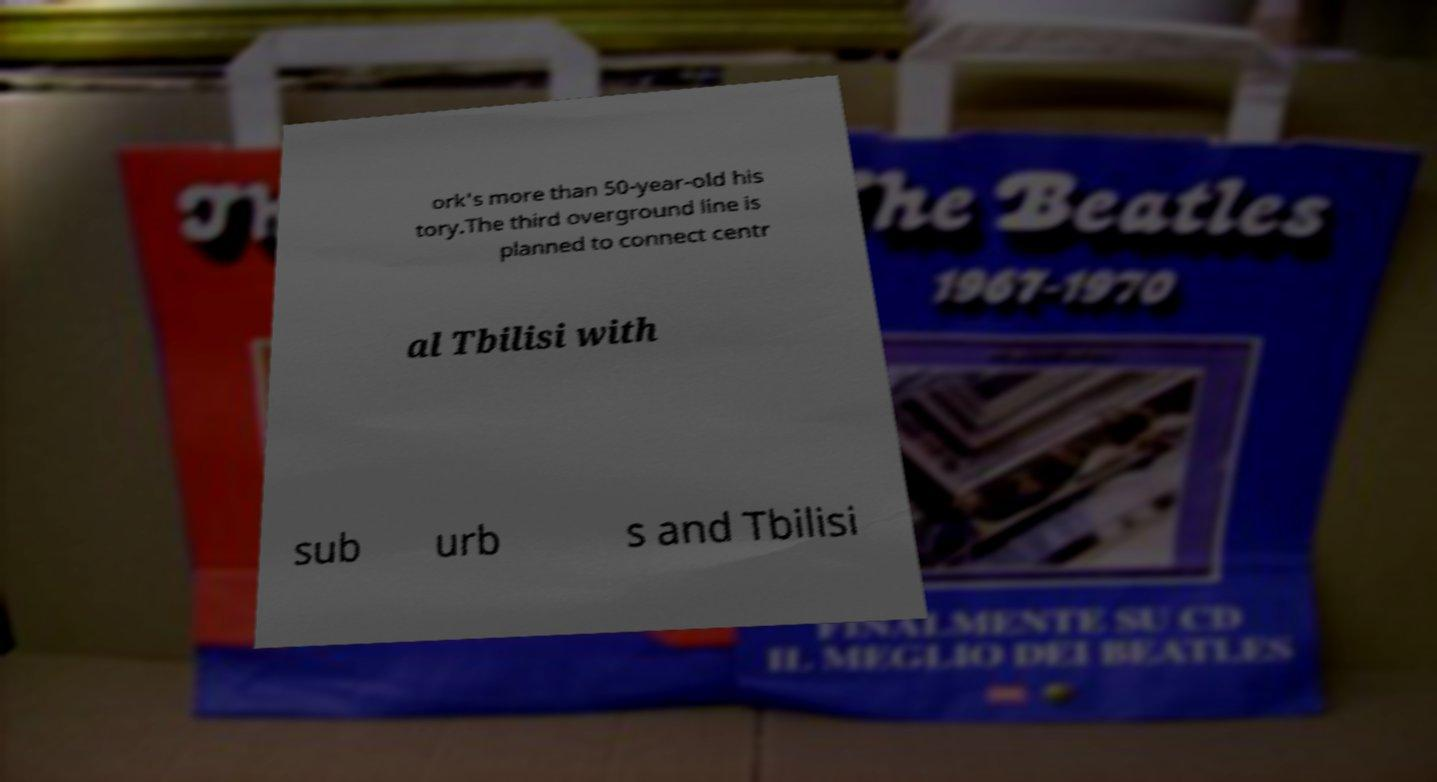Can you accurately transcribe the text from the provided image for me? ork's more than 50-year-old his tory.The third overground line is planned to connect centr al Tbilisi with sub urb s and Tbilisi 